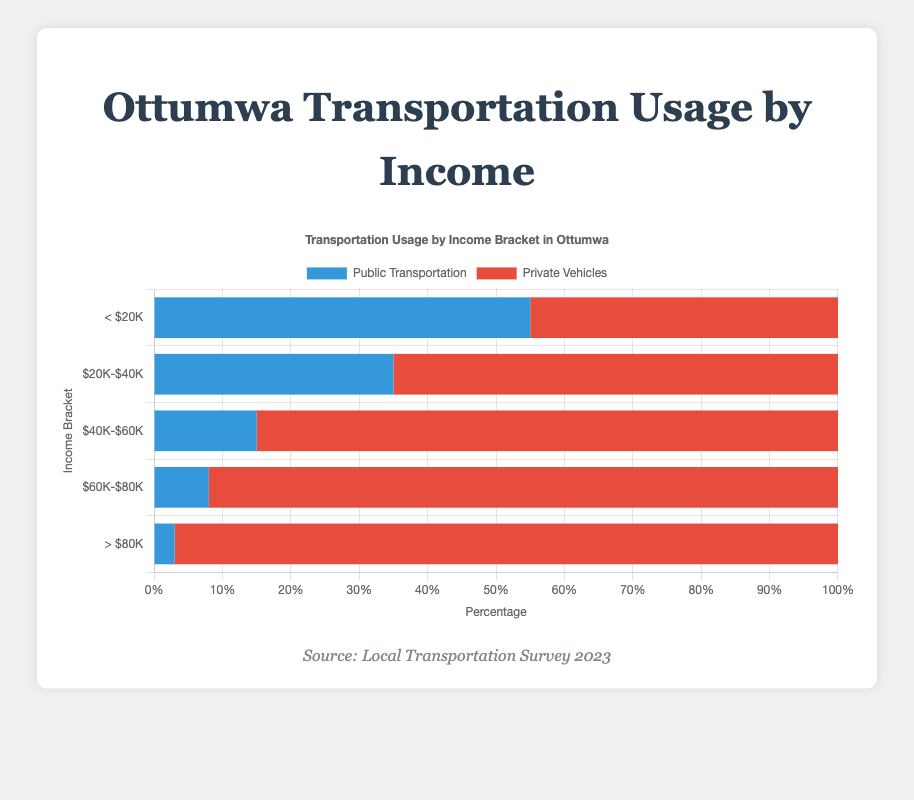What's the percentage of people using public transportation in the <$20K income bracket? Look at the first bar for Public Transportation, which corresponds to the <$20K income bracket. The number is 55%.
Answer: 55% How does the usage of private vehicles among the $40K-$60K income bracket compare to the <$20K income bracket? For the $40K-$60K income bracket, the usage of private vehicles is 85%. For the <$20K bracket, it's 45%. 85% is greater than 45%.
Answer: The $40K-$60K bracket uses private vehicles more What is the total usage (public + private) of transportation in the $60K-$80K income bracket? Add the public transportation usage (8%) and the private vehicles usage (92%) for the $60K-$80K income bracket. 8% + 92% = 100%.
Answer: 100% Which income bracket has the highest percentage of private vehicle usage? Observe the bars for Private Vehicles across all income brackets and identify the highest. The >$80K bracket has a usage of 97%, which is the highest.
Answer: >$80K Between the $20K-$40K and $40K-$60K income brackets, which one has a higher percentage of public transportation usage and by how much? Public transportation usage for $20K-$40K is 35% and for $40K-$60K is 15%. The difference is 35% - 15% = 20%.
Answer: $20K-$40K by 20% What is the difference in the percentage of public transportation usage between the lowest and the highest income brackets? Public transportation usage in the <$20K bracket is 55%, and in the >$80K bracket, it is 3%. The difference is 55% - 3% = 52%.
Answer: 52% Comparing public transportation across income brackets, which bracket shows the steepest decline in usage from the previous bracket? Public transportation for <$20K is 55%, $20K-$40K is 35%, $40K-$60K is 15%, $60K-$80K is 8%, and >$80K is 3%. The steepest decline is between $20K-$40K and $40K-$60K, going from 35% to 15%, a 20% drop.
Answer: $20K-$40K to $40K-$60K Given the visual attributes, how does the color of the bars help distinguish between public transportation and private vehicle usage? Public transportation bars are colored blue, and private vehicle bars are colored red. This color coding helps easily distinguish between the two categories.
Answer: Blue for public transportation, red for private vehicles 